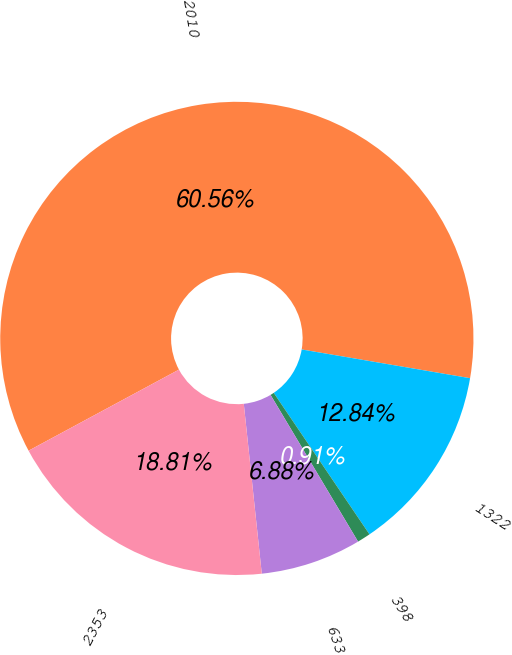Convert chart. <chart><loc_0><loc_0><loc_500><loc_500><pie_chart><fcel>2010<fcel>1322<fcel>398<fcel>633<fcel>2353<nl><fcel>60.56%<fcel>12.84%<fcel>0.91%<fcel>6.88%<fcel>18.81%<nl></chart> 